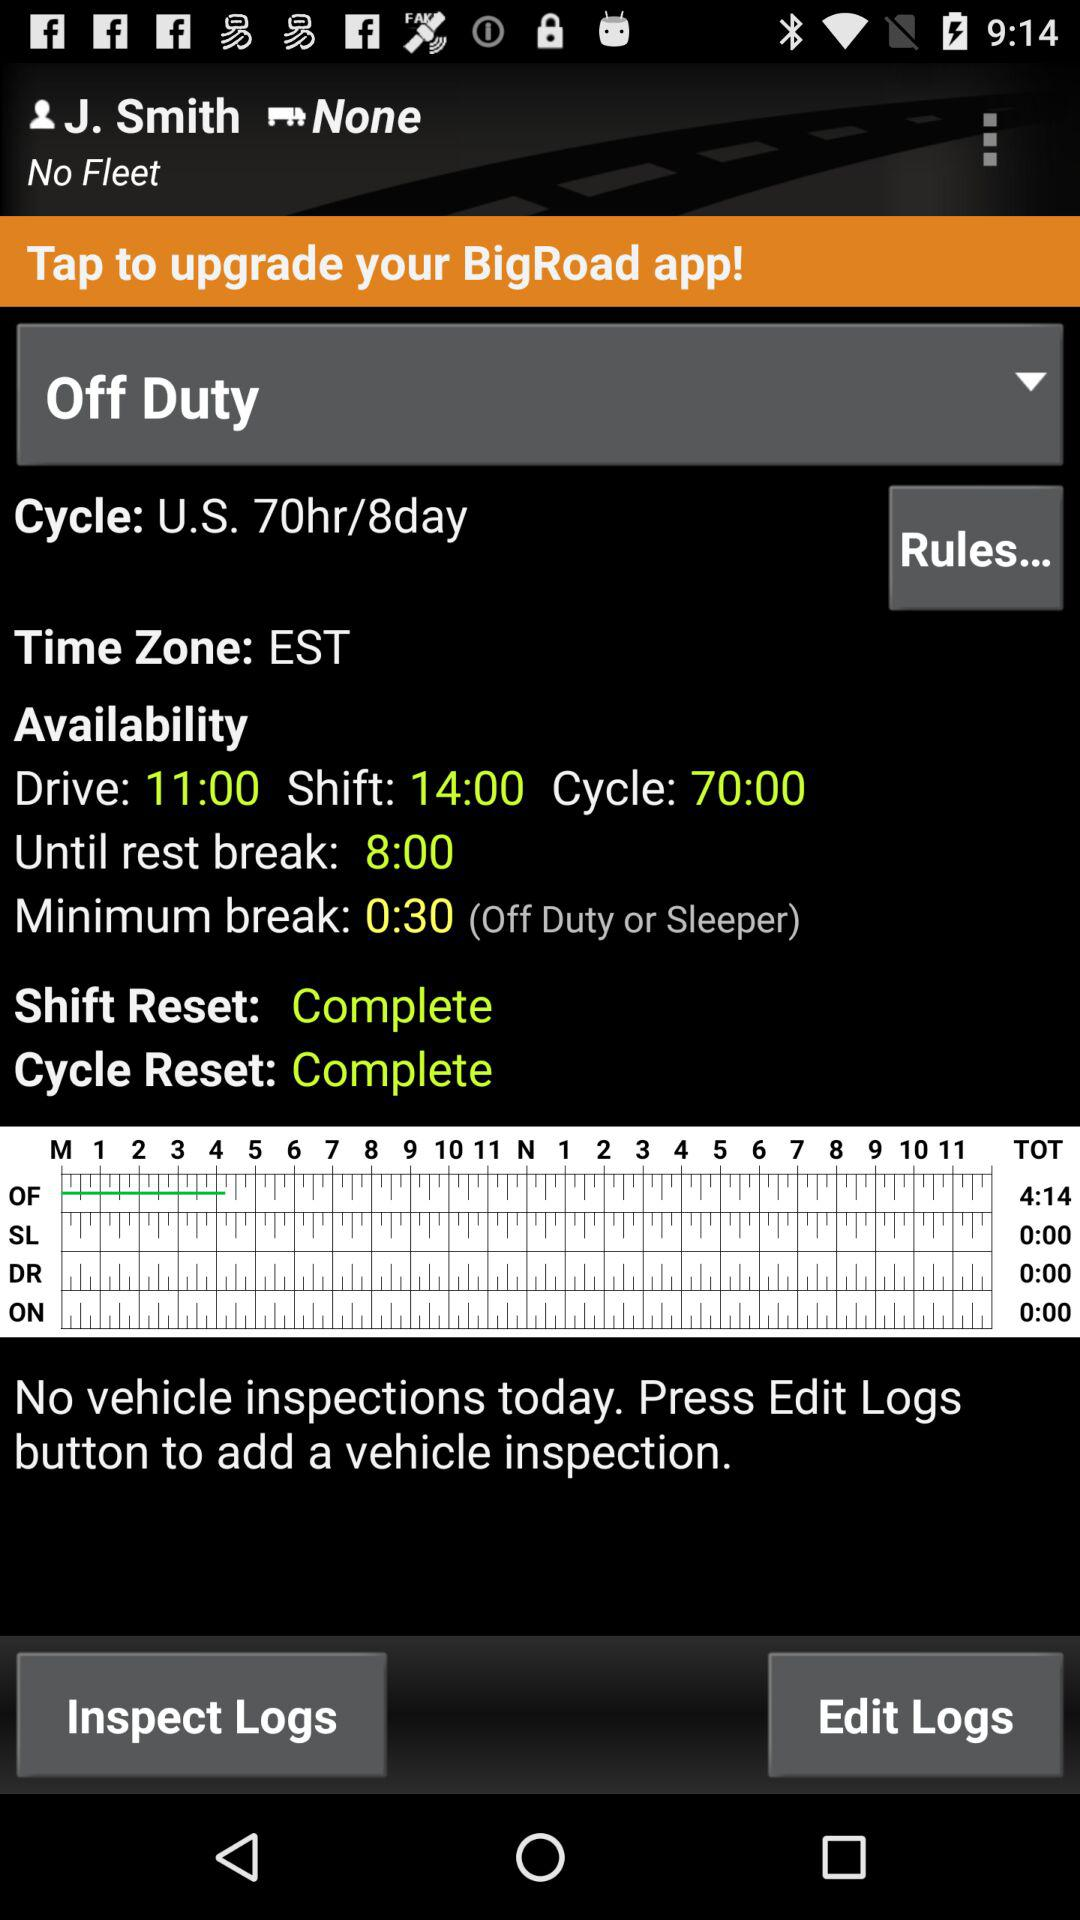What is the duration of the minimum break? The duration of the minimum break is 30 seconds. 